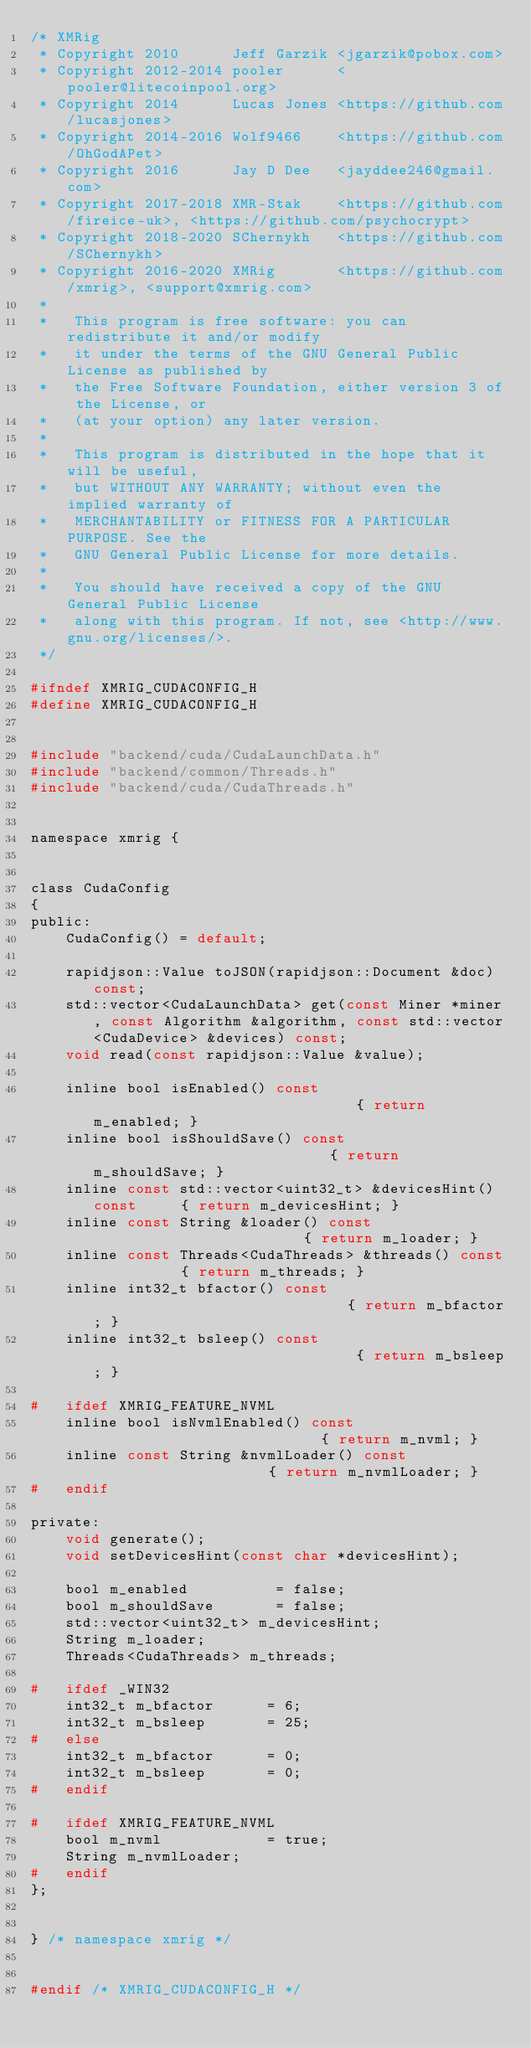<code> <loc_0><loc_0><loc_500><loc_500><_C_>/* XMRig
 * Copyright 2010      Jeff Garzik <jgarzik@pobox.com>
 * Copyright 2012-2014 pooler      <pooler@litecoinpool.org>
 * Copyright 2014      Lucas Jones <https://github.com/lucasjones>
 * Copyright 2014-2016 Wolf9466    <https://github.com/OhGodAPet>
 * Copyright 2016      Jay D Dee   <jayddee246@gmail.com>
 * Copyright 2017-2018 XMR-Stak    <https://github.com/fireice-uk>, <https://github.com/psychocrypt>
 * Copyright 2018-2020 SChernykh   <https://github.com/SChernykh>
 * Copyright 2016-2020 XMRig       <https://github.com/xmrig>, <support@xmrig.com>
 *
 *   This program is free software: you can redistribute it and/or modify
 *   it under the terms of the GNU General Public License as published by
 *   the Free Software Foundation, either version 3 of the License, or
 *   (at your option) any later version.
 *
 *   This program is distributed in the hope that it will be useful,
 *   but WITHOUT ANY WARRANTY; without even the implied warranty of
 *   MERCHANTABILITY or FITNESS FOR A PARTICULAR PURPOSE. See the
 *   GNU General Public License for more details.
 *
 *   You should have received a copy of the GNU General Public License
 *   along with this program. If not, see <http://www.gnu.org/licenses/>.
 */

#ifndef XMRIG_CUDACONFIG_H
#define XMRIG_CUDACONFIG_H


#include "backend/cuda/CudaLaunchData.h"
#include "backend/common/Threads.h"
#include "backend/cuda/CudaThreads.h"


namespace xmrig {


class CudaConfig
{
public:
    CudaConfig() = default;

    rapidjson::Value toJSON(rapidjson::Document &doc) const;
    std::vector<CudaLaunchData> get(const Miner *miner, const Algorithm &algorithm, const std::vector<CudaDevice> &devices) const;
    void read(const rapidjson::Value &value);

    inline bool isEnabled() const                               { return m_enabled; }
    inline bool isShouldSave() const                            { return m_shouldSave; }
    inline const std::vector<uint32_t> &devicesHint() const     { return m_devicesHint; }
    inline const String &loader() const                         { return m_loader; }
    inline const Threads<CudaThreads> &threads() const          { return m_threads; }
    inline int32_t bfactor() const                              { return m_bfactor; }
    inline int32_t bsleep() const                               { return m_bsleep; }

#   ifdef XMRIG_FEATURE_NVML
    inline bool isNvmlEnabled() const                           { return m_nvml; }
    inline const String &nvmlLoader() const                     { return m_nvmlLoader; }
#   endif

private:
    void generate();
    void setDevicesHint(const char *devicesHint);

    bool m_enabled          = false;
    bool m_shouldSave       = false;
    std::vector<uint32_t> m_devicesHint;
    String m_loader;
    Threads<CudaThreads> m_threads;

#   ifdef _WIN32
    int32_t m_bfactor      = 6;
    int32_t m_bsleep       = 25;
#   else
    int32_t m_bfactor      = 0;
    int32_t m_bsleep       = 0;
#   endif

#   ifdef XMRIG_FEATURE_NVML
    bool m_nvml            = true;
    String m_nvmlLoader;
#   endif
};


} /* namespace xmrig */


#endif /* XMRIG_CUDACONFIG_H */
</code> 